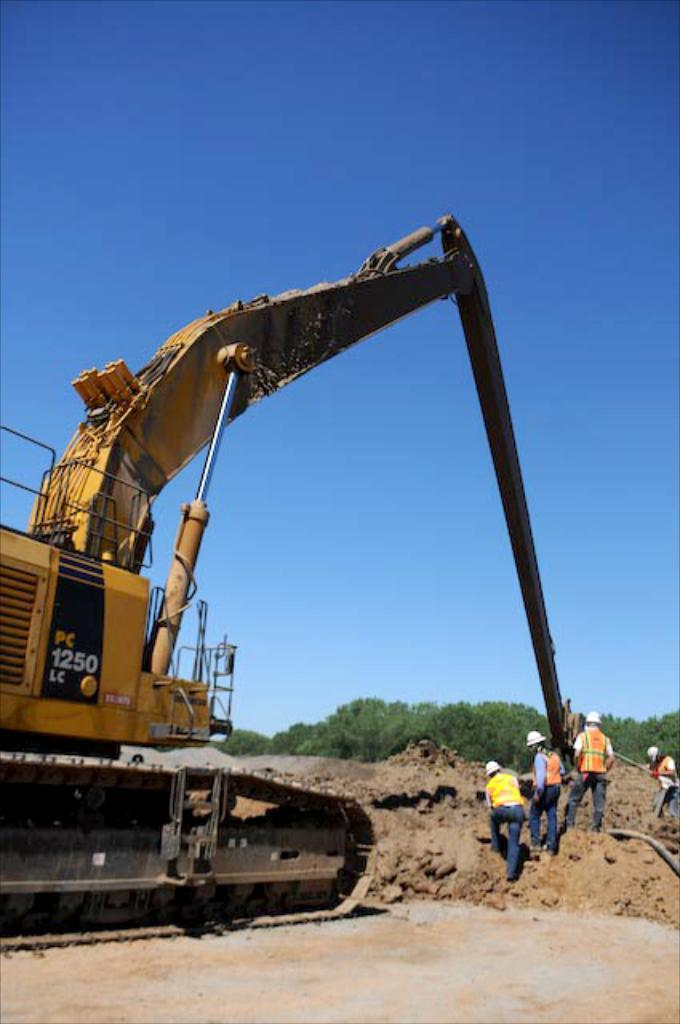What is the main subject of the image? The main subject of the image is a group of people. What else can be seen in the image besides the group of people? There is an earth-moving vehicle in the image. What can be seen in the background of the image? There are trees in the background of the image. Where is the basin located in the image? There is no basin present in the image. What type of stick is being used by the people in the image? There is no stick being used by the people in the image. 